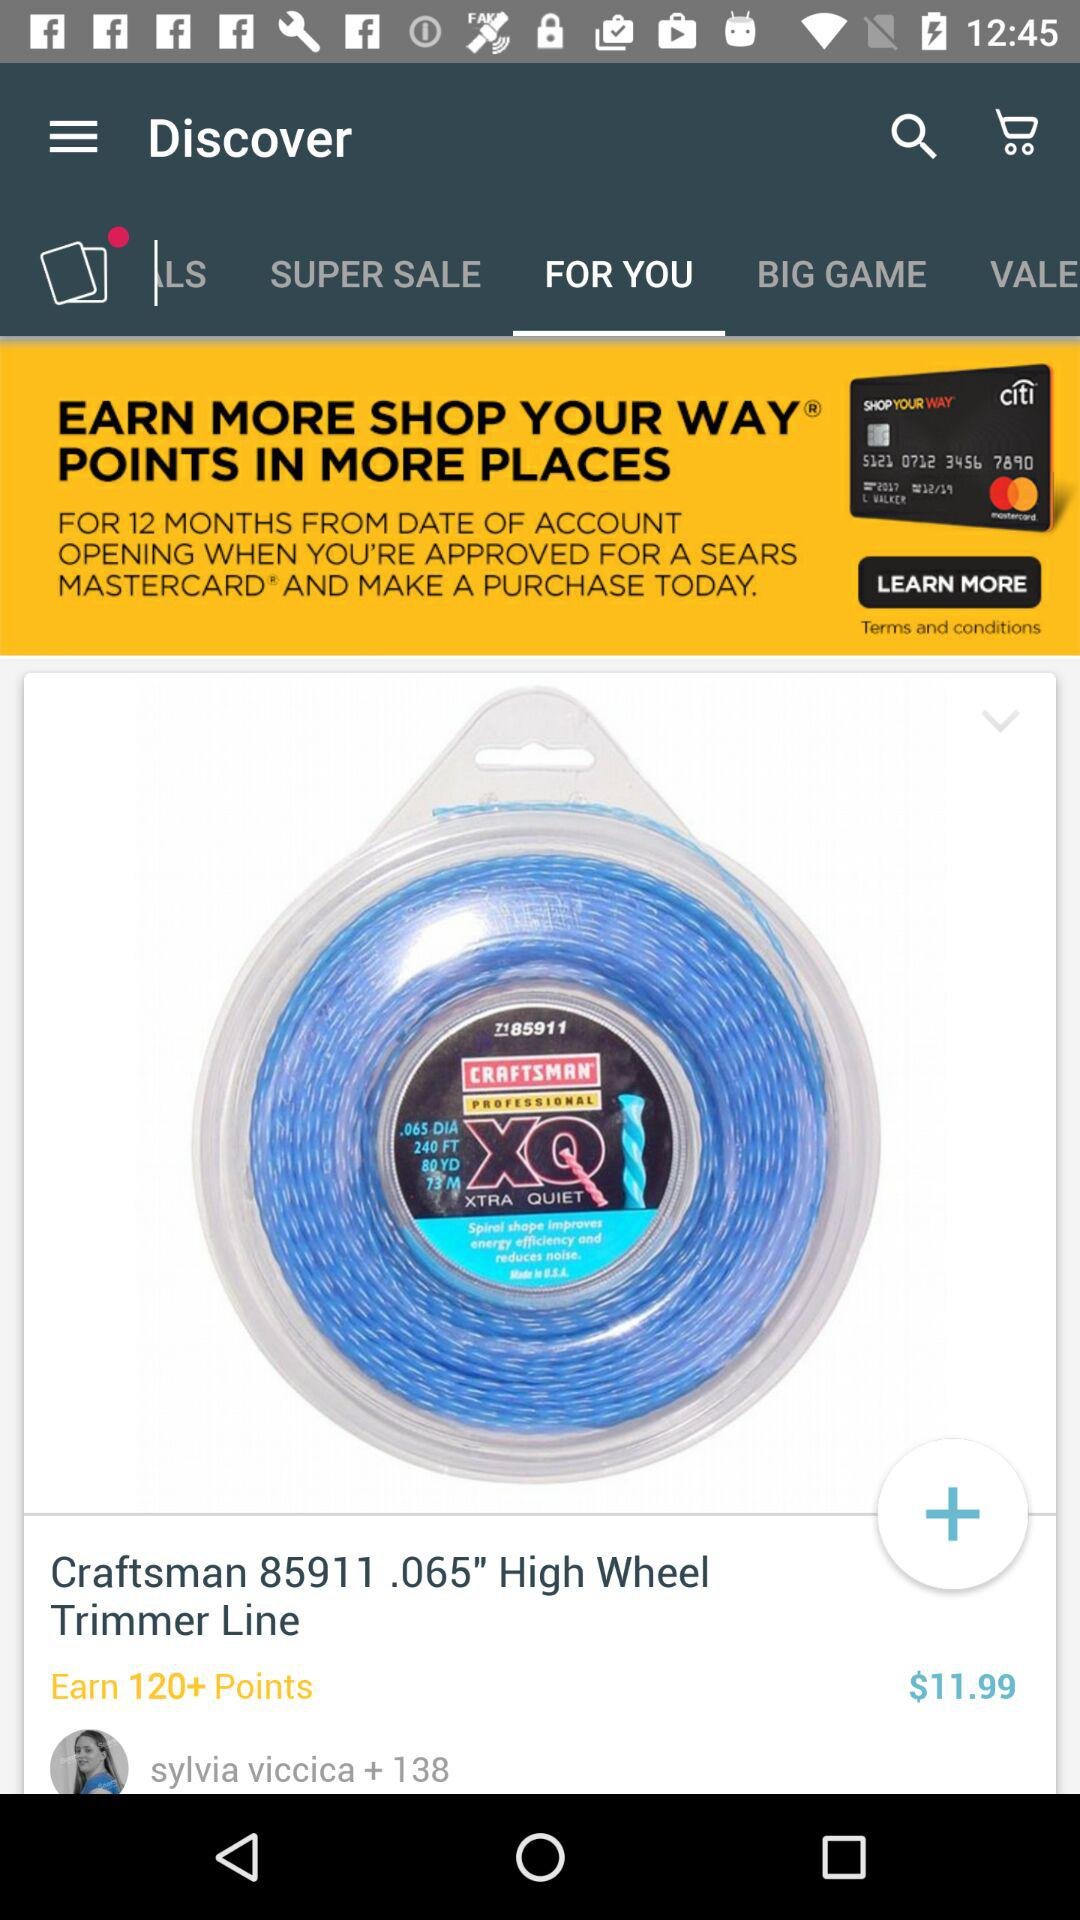What is the price of the "Craftsman 85911.065" High Wheel Trimmer Line"? The price is $11.99. 